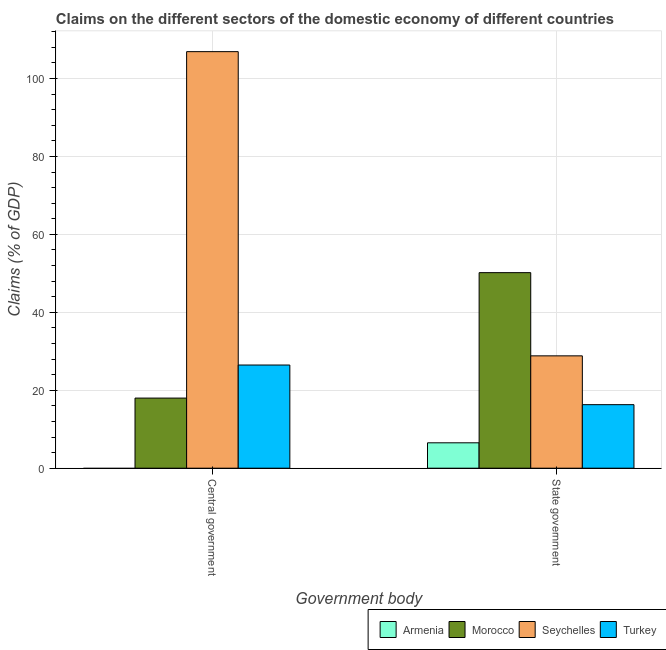How many different coloured bars are there?
Provide a short and direct response. 4. How many groups of bars are there?
Provide a succinct answer. 2. Are the number of bars per tick equal to the number of legend labels?
Your answer should be compact. No. Are the number of bars on each tick of the X-axis equal?
Offer a terse response. No. How many bars are there on the 2nd tick from the left?
Ensure brevity in your answer.  4. What is the label of the 1st group of bars from the left?
Your answer should be very brief. Central government. What is the claims on state government in Armenia?
Offer a terse response. 6.51. Across all countries, what is the maximum claims on central government?
Provide a short and direct response. 106.88. In which country was the claims on state government maximum?
Ensure brevity in your answer.  Morocco. What is the total claims on central government in the graph?
Provide a short and direct response. 151.35. What is the difference between the claims on central government in Morocco and that in Turkey?
Ensure brevity in your answer.  -8.48. What is the difference between the claims on state government in Armenia and the claims on central government in Morocco?
Offer a very short reply. -11.48. What is the average claims on state government per country?
Give a very brief answer. 25.45. What is the difference between the claims on central government and claims on state government in Morocco?
Your response must be concise. -32.19. In how many countries, is the claims on state government greater than 60 %?
Offer a very short reply. 0. What is the ratio of the claims on central government in Turkey to that in Seychelles?
Provide a short and direct response. 0.25. What is the difference between two consecutive major ticks on the Y-axis?
Your response must be concise. 20. Are the values on the major ticks of Y-axis written in scientific E-notation?
Provide a short and direct response. No. Where does the legend appear in the graph?
Your response must be concise. Bottom right. How many legend labels are there?
Provide a short and direct response. 4. What is the title of the graph?
Offer a very short reply. Claims on the different sectors of the domestic economy of different countries. What is the label or title of the X-axis?
Provide a succinct answer. Government body. What is the label or title of the Y-axis?
Make the answer very short. Claims (% of GDP). What is the Claims (% of GDP) in Morocco in Central government?
Provide a short and direct response. 17.99. What is the Claims (% of GDP) in Seychelles in Central government?
Keep it short and to the point. 106.88. What is the Claims (% of GDP) in Turkey in Central government?
Provide a succinct answer. 26.47. What is the Claims (% of GDP) in Armenia in State government?
Offer a very short reply. 6.51. What is the Claims (% of GDP) in Morocco in State government?
Ensure brevity in your answer.  50.18. What is the Claims (% of GDP) of Seychelles in State government?
Your response must be concise. 28.83. What is the Claims (% of GDP) in Turkey in State government?
Ensure brevity in your answer.  16.3. Across all Government body, what is the maximum Claims (% of GDP) of Armenia?
Your response must be concise. 6.51. Across all Government body, what is the maximum Claims (% of GDP) in Morocco?
Your answer should be very brief. 50.18. Across all Government body, what is the maximum Claims (% of GDP) in Seychelles?
Offer a terse response. 106.88. Across all Government body, what is the maximum Claims (% of GDP) of Turkey?
Keep it short and to the point. 26.47. Across all Government body, what is the minimum Claims (% of GDP) in Armenia?
Your answer should be compact. 0. Across all Government body, what is the minimum Claims (% of GDP) of Morocco?
Your response must be concise. 17.99. Across all Government body, what is the minimum Claims (% of GDP) of Seychelles?
Your answer should be compact. 28.83. Across all Government body, what is the minimum Claims (% of GDP) of Turkey?
Provide a succinct answer. 16.3. What is the total Claims (% of GDP) in Armenia in the graph?
Give a very brief answer. 6.51. What is the total Claims (% of GDP) of Morocco in the graph?
Your response must be concise. 68.17. What is the total Claims (% of GDP) in Seychelles in the graph?
Your answer should be compact. 135.71. What is the total Claims (% of GDP) in Turkey in the graph?
Your answer should be compact. 42.77. What is the difference between the Claims (% of GDP) in Morocco in Central government and that in State government?
Give a very brief answer. -32.19. What is the difference between the Claims (% of GDP) in Seychelles in Central government and that in State government?
Your answer should be very brief. 78.06. What is the difference between the Claims (% of GDP) in Turkey in Central government and that in State government?
Provide a short and direct response. 10.17. What is the difference between the Claims (% of GDP) in Morocco in Central government and the Claims (% of GDP) in Seychelles in State government?
Provide a short and direct response. -10.84. What is the difference between the Claims (% of GDP) of Morocco in Central government and the Claims (% of GDP) of Turkey in State government?
Your answer should be very brief. 1.69. What is the difference between the Claims (% of GDP) in Seychelles in Central government and the Claims (% of GDP) in Turkey in State government?
Ensure brevity in your answer.  90.58. What is the average Claims (% of GDP) in Armenia per Government body?
Ensure brevity in your answer.  3.26. What is the average Claims (% of GDP) of Morocco per Government body?
Your response must be concise. 34.08. What is the average Claims (% of GDP) of Seychelles per Government body?
Your answer should be very brief. 67.85. What is the average Claims (% of GDP) of Turkey per Government body?
Your response must be concise. 21.39. What is the difference between the Claims (% of GDP) in Morocco and Claims (% of GDP) in Seychelles in Central government?
Offer a very short reply. -88.89. What is the difference between the Claims (% of GDP) in Morocco and Claims (% of GDP) in Turkey in Central government?
Offer a very short reply. -8.48. What is the difference between the Claims (% of GDP) of Seychelles and Claims (% of GDP) of Turkey in Central government?
Your response must be concise. 80.41. What is the difference between the Claims (% of GDP) of Armenia and Claims (% of GDP) of Morocco in State government?
Provide a short and direct response. -43.66. What is the difference between the Claims (% of GDP) in Armenia and Claims (% of GDP) in Seychelles in State government?
Keep it short and to the point. -22.31. What is the difference between the Claims (% of GDP) of Armenia and Claims (% of GDP) of Turkey in State government?
Your response must be concise. -9.79. What is the difference between the Claims (% of GDP) of Morocco and Claims (% of GDP) of Seychelles in State government?
Offer a very short reply. 21.35. What is the difference between the Claims (% of GDP) of Morocco and Claims (% of GDP) of Turkey in State government?
Your answer should be very brief. 33.88. What is the difference between the Claims (% of GDP) of Seychelles and Claims (% of GDP) of Turkey in State government?
Keep it short and to the point. 12.53. What is the ratio of the Claims (% of GDP) of Morocco in Central government to that in State government?
Your answer should be compact. 0.36. What is the ratio of the Claims (% of GDP) of Seychelles in Central government to that in State government?
Provide a succinct answer. 3.71. What is the ratio of the Claims (% of GDP) of Turkey in Central government to that in State government?
Your response must be concise. 1.62. What is the difference between the highest and the second highest Claims (% of GDP) of Morocco?
Your answer should be compact. 32.19. What is the difference between the highest and the second highest Claims (% of GDP) in Seychelles?
Ensure brevity in your answer.  78.06. What is the difference between the highest and the second highest Claims (% of GDP) in Turkey?
Your response must be concise. 10.17. What is the difference between the highest and the lowest Claims (% of GDP) of Armenia?
Your response must be concise. 6.51. What is the difference between the highest and the lowest Claims (% of GDP) of Morocco?
Offer a very short reply. 32.19. What is the difference between the highest and the lowest Claims (% of GDP) of Seychelles?
Your answer should be very brief. 78.06. What is the difference between the highest and the lowest Claims (% of GDP) in Turkey?
Your response must be concise. 10.17. 